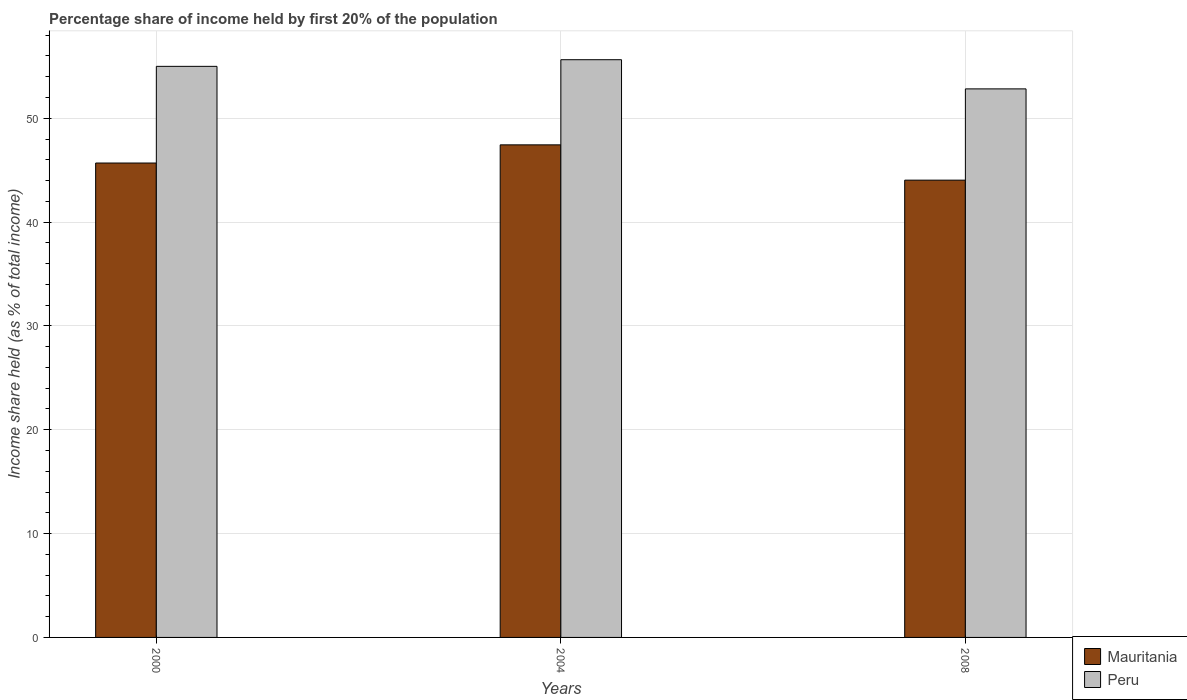Are the number of bars on each tick of the X-axis equal?
Make the answer very short. Yes. What is the label of the 1st group of bars from the left?
Keep it short and to the point. 2000. What is the share of income held by first 20% of the population in Mauritania in 2004?
Make the answer very short. 47.44. Across all years, what is the maximum share of income held by first 20% of the population in Peru?
Ensure brevity in your answer.  55.64. Across all years, what is the minimum share of income held by first 20% of the population in Mauritania?
Ensure brevity in your answer.  44.04. In which year was the share of income held by first 20% of the population in Peru maximum?
Keep it short and to the point. 2004. What is the total share of income held by first 20% of the population in Mauritania in the graph?
Your answer should be very brief. 137.17. What is the difference between the share of income held by first 20% of the population in Mauritania in 2000 and that in 2004?
Keep it short and to the point. -1.75. What is the difference between the share of income held by first 20% of the population in Mauritania in 2000 and the share of income held by first 20% of the population in Peru in 2004?
Ensure brevity in your answer.  -9.95. What is the average share of income held by first 20% of the population in Peru per year?
Offer a very short reply. 54.49. In the year 2008, what is the difference between the share of income held by first 20% of the population in Peru and share of income held by first 20% of the population in Mauritania?
Give a very brief answer. 8.79. In how many years, is the share of income held by first 20% of the population in Mauritania greater than 10 %?
Offer a very short reply. 3. What is the ratio of the share of income held by first 20% of the population in Peru in 2000 to that in 2004?
Give a very brief answer. 0.99. Is the share of income held by first 20% of the population in Peru in 2000 less than that in 2004?
Keep it short and to the point. Yes. Is the difference between the share of income held by first 20% of the population in Peru in 2000 and 2008 greater than the difference between the share of income held by first 20% of the population in Mauritania in 2000 and 2008?
Keep it short and to the point. Yes. What is the difference between the highest and the second highest share of income held by first 20% of the population in Peru?
Provide a short and direct response. 0.64. What is the difference between the highest and the lowest share of income held by first 20% of the population in Peru?
Your answer should be very brief. 2.81. In how many years, is the share of income held by first 20% of the population in Peru greater than the average share of income held by first 20% of the population in Peru taken over all years?
Keep it short and to the point. 2. What does the 1st bar from the right in 2008 represents?
Offer a terse response. Peru. Are all the bars in the graph horizontal?
Your answer should be compact. No. Does the graph contain any zero values?
Give a very brief answer. No. Does the graph contain grids?
Keep it short and to the point. Yes. How many legend labels are there?
Ensure brevity in your answer.  2. How are the legend labels stacked?
Provide a short and direct response. Vertical. What is the title of the graph?
Offer a terse response. Percentage share of income held by first 20% of the population. What is the label or title of the X-axis?
Your answer should be very brief. Years. What is the label or title of the Y-axis?
Give a very brief answer. Income share held (as % of total income). What is the Income share held (as % of total income) in Mauritania in 2000?
Your response must be concise. 45.69. What is the Income share held (as % of total income) of Mauritania in 2004?
Offer a terse response. 47.44. What is the Income share held (as % of total income) in Peru in 2004?
Provide a succinct answer. 55.64. What is the Income share held (as % of total income) in Mauritania in 2008?
Make the answer very short. 44.04. What is the Income share held (as % of total income) in Peru in 2008?
Your answer should be compact. 52.83. Across all years, what is the maximum Income share held (as % of total income) in Mauritania?
Offer a terse response. 47.44. Across all years, what is the maximum Income share held (as % of total income) in Peru?
Your response must be concise. 55.64. Across all years, what is the minimum Income share held (as % of total income) in Mauritania?
Your response must be concise. 44.04. Across all years, what is the minimum Income share held (as % of total income) of Peru?
Offer a very short reply. 52.83. What is the total Income share held (as % of total income) in Mauritania in the graph?
Ensure brevity in your answer.  137.17. What is the total Income share held (as % of total income) of Peru in the graph?
Provide a succinct answer. 163.47. What is the difference between the Income share held (as % of total income) in Mauritania in 2000 and that in 2004?
Provide a succinct answer. -1.75. What is the difference between the Income share held (as % of total income) in Peru in 2000 and that in 2004?
Provide a succinct answer. -0.64. What is the difference between the Income share held (as % of total income) of Mauritania in 2000 and that in 2008?
Offer a terse response. 1.65. What is the difference between the Income share held (as % of total income) in Peru in 2000 and that in 2008?
Your answer should be compact. 2.17. What is the difference between the Income share held (as % of total income) of Mauritania in 2004 and that in 2008?
Offer a very short reply. 3.4. What is the difference between the Income share held (as % of total income) of Peru in 2004 and that in 2008?
Offer a terse response. 2.81. What is the difference between the Income share held (as % of total income) of Mauritania in 2000 and the Income share held (as % of total income) of Peru in 2004?
Your answer should be compact. -9.95. What is the difference between the Income share held (as % of total income) of Mauritania in 2000 and the Income share held (as % of total income) of Peru in 2008?
Provide a succinct answer. -7.14. What is the difference between the Income share held (as % of total income) of Mauritania in 2004 and the Income share held (as % of total income) of Peru in 2008?
Provide a short and direct response. -5.39. What is the average Income share held (as % of total income) of Mauritania per year?
Offer a very short reply. 45.72. What is the average Income share held (as % of total income) of Peru per year?
Your answer should be compact. 54.49. In the year 2000, what is the difference between the Income share held (as % of total income) in Mauritania and Income share held (as % of total income) in Peru?
Your answer should be compact. -9.31. In the year 2008, what is the difference between the Income share held (as % of total income) in Mauritania and Income share held (as % of total income) in Peru?
Your response must be concise. -8.79. What is the ratio of the Income share held (as % of total income) in Mauritania in 2000 to that in 2004?
Provide a succinct answer. 0.96. What is the ratio of the Income share held (as % of total income) in Mauritania in 2000 to that in 2008?
Your answer should be compact. 1.04. What is the ratio of the Income share held (as % of total income) in Peru in 2000 to that in 2008?
Your answer should be compact. 1.04. What is the ratio of the Income share held (as % of total income) in Mauritania in 2004 to that in 2008?
Provide a short and direct response. 1.08. What is the ratio of the Income share held (as % of total income) in Peru in 2004 to that in 2008?
Your answer should be very brief. 1.05. What is the difference between the highest and the second highest Income share held (as % of total income) of Mauritania?
Offer a terse response. 1.75. What is the difference between the highest and the second highest Income share held (as % of total income) of Peru?
Offer a very short reply. 0.64. What is the difference between the highest and the lowest Income share held (as % of total income) in Mauritania?
Offer a terse response. 3.4. What is the difference between the highest and the lowest Income share held (as % of total income) of Peru?
Keep it short and to the point. 2.81. 